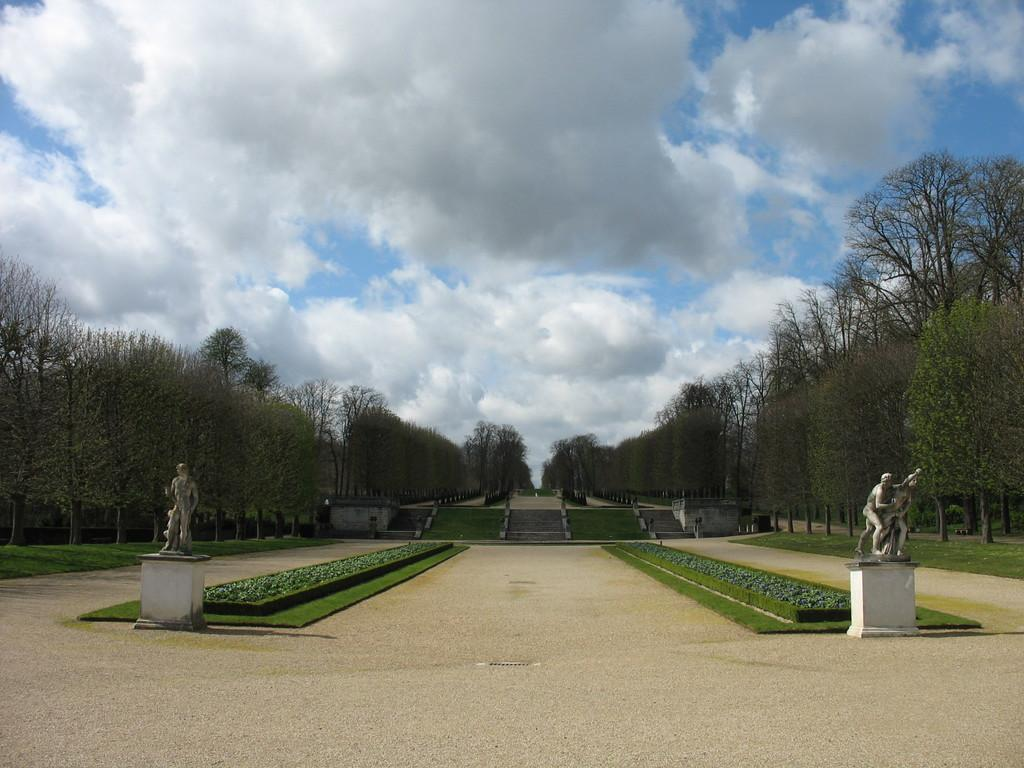What type of art is present in the image? There are sculptures in the image. What architectural feature can be seen in the image? There are staircases in the image. What material is present in the image? There is glass in the image. What type of natural environment is visible in the image? Trees are visible around the image. How does the marble turn in the image? There is no marble present in the image, and therefore no such action can be observed. What type of water is visible in the image? There is no water present in the image. 